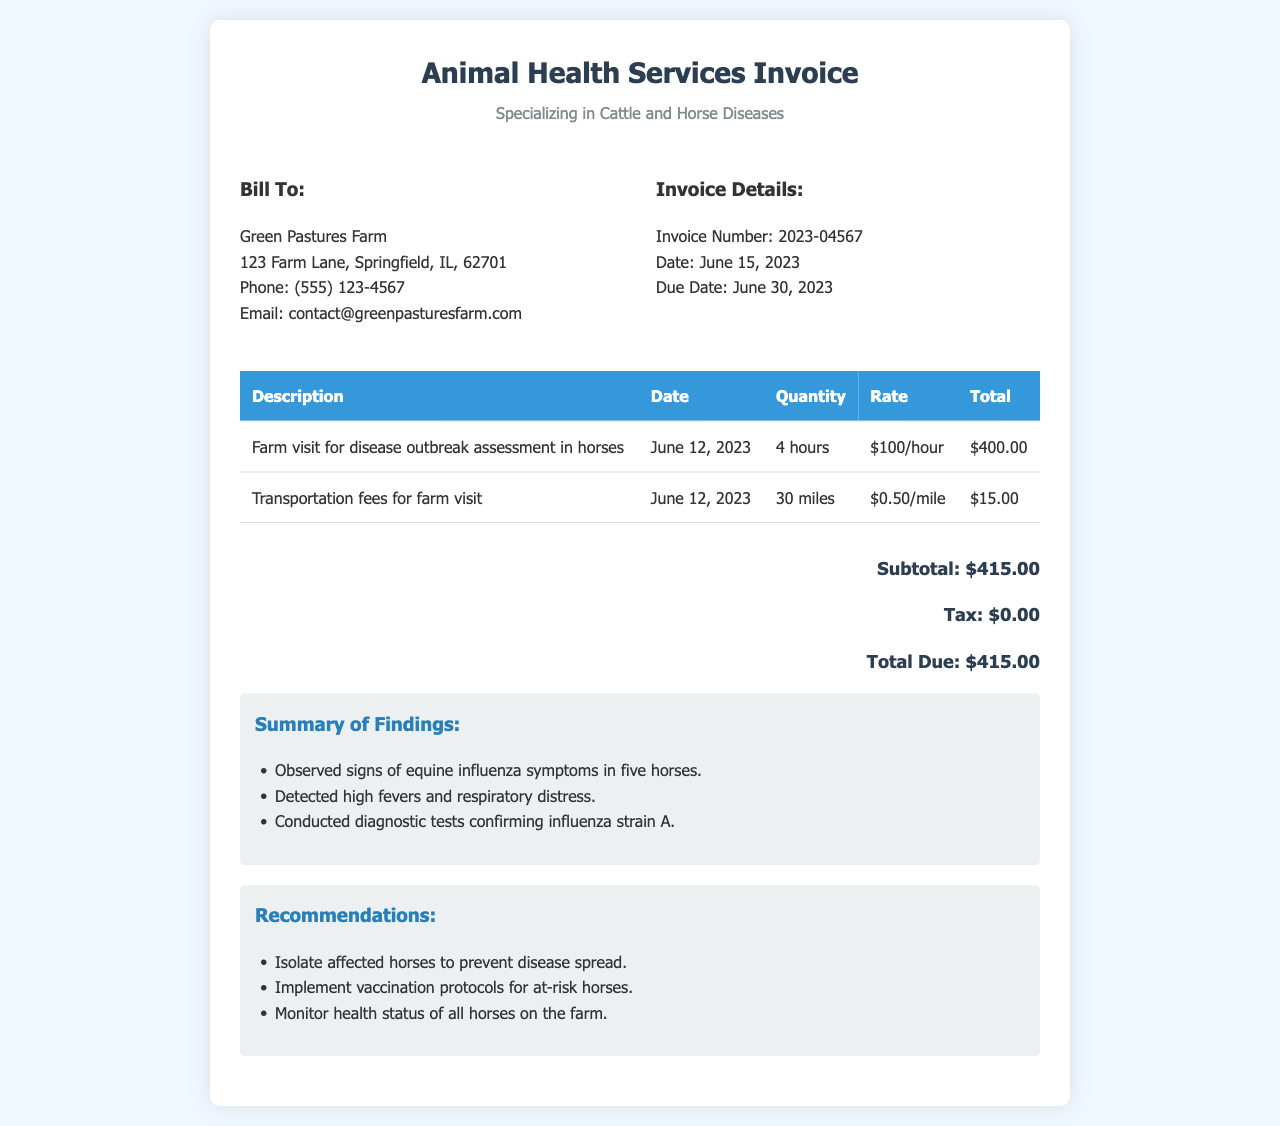What is the invoice number? The invoice number is specifically listed in the document for reference.
Answer: 2023-04567 What is the due date for payment? The due date for payment is mentioned in the invoice details section.
Answer: June 30, 2023 How many hours were billed for the farm visit? The description states the quantity of hours billed for the visit.
Answer: 4 hours What was the transportation fee per mile? The rate for transportation fees is clearly stated in the invoice table.
Answer: $0.50/mile What is the total amount due? The total amount due is explicitly stated at the bottom of the invoice.
Answer: $415.00 How many horses showed signs of disease? The findings section quantifies the number of affected horses.
Answer: five horses What disease was confirmed through diagnostic tests? The findings summarize the confirmed diagnostic results.
Answer: influenza strain A What is one of the recommendations provided? The recommendations section lists multiple actions to take; one example suffices as an answer.
Answer: Isolate affected horses 